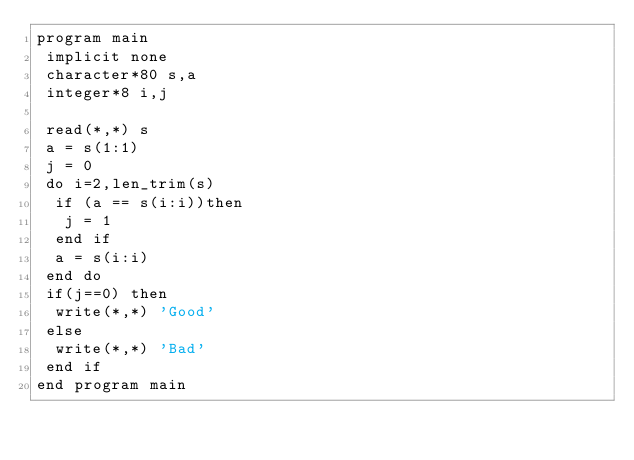Convert code to text. <code><loc_0><loc_0><loc_500><loc_500><_FORTRAN_>program main
 implicit none
 character*80 s,a
 integer*8 i,j
 
 read(*,*) s
 a = s(1:1)
 j = 0
 do i=2,len_trim(s)
  if (a == s(i:i))then
   j = 1
  end if
  a = s(i:i)
 end do
 if(j==0) then
  write(*,*) 'Good'
 else
  write(*,*) 'Bad'
 end if
end program main</code> 